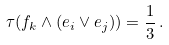Convert formula to latex. <formula><loc_0><loc_0><loc_500><loc_500>\tau ( f _ { k } \wedge ( e _ { i } \vee e _ { j } ) ) = \frac { 1 } { 3 } \, .</formula> 